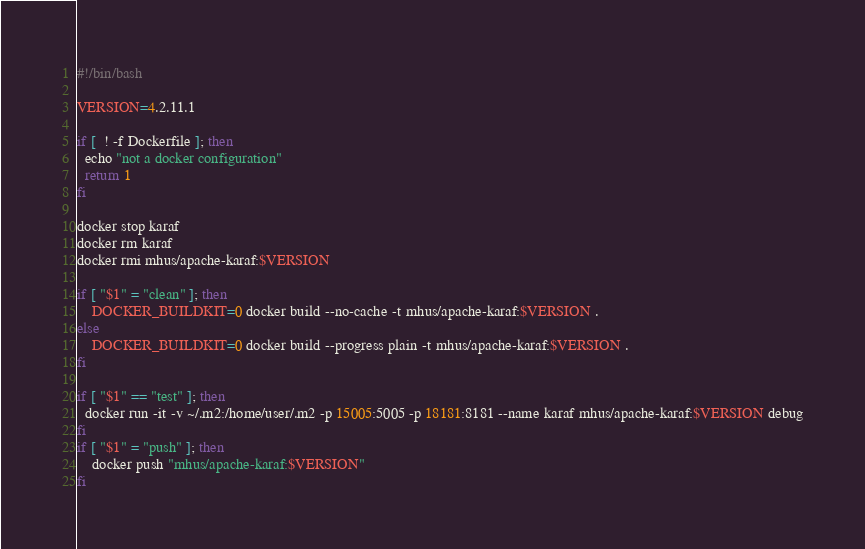<code> <loc_0><loc_0><loc_500><loc_500><_Bash_>#!/bin/bash

VERSION=4.2.11.1

if [  ! -f Dockerfile ]; then
  echo "not a docker configuration"
  return 1
fi

docker stop karaf
docker rm karaf
docker rmi mhus/apache-karaf:$VERSION

if [ "$1" = "clean" ]; then
	DOCKER_BUILDKIT=0 docker build --no-cache -t mhus/apache-karaf:$VERSION .
else
	DOCKER_BUILDKIT=0 docker build --progress plain -t mhus/apache-karaf:$VERSION .
fi

if [ "$1" == "test" ]; then
  docker run -it -v ~/.m2:/home/user/.m2 -p 15005:5005 -p 18181:8181 --name karaf mhus/apache-karaf:$VERSION debug
fi
if [ "$1" = "push" ]; then
    docker push "mhus/apache-karaf:$VERSION"
fi 
</code> 